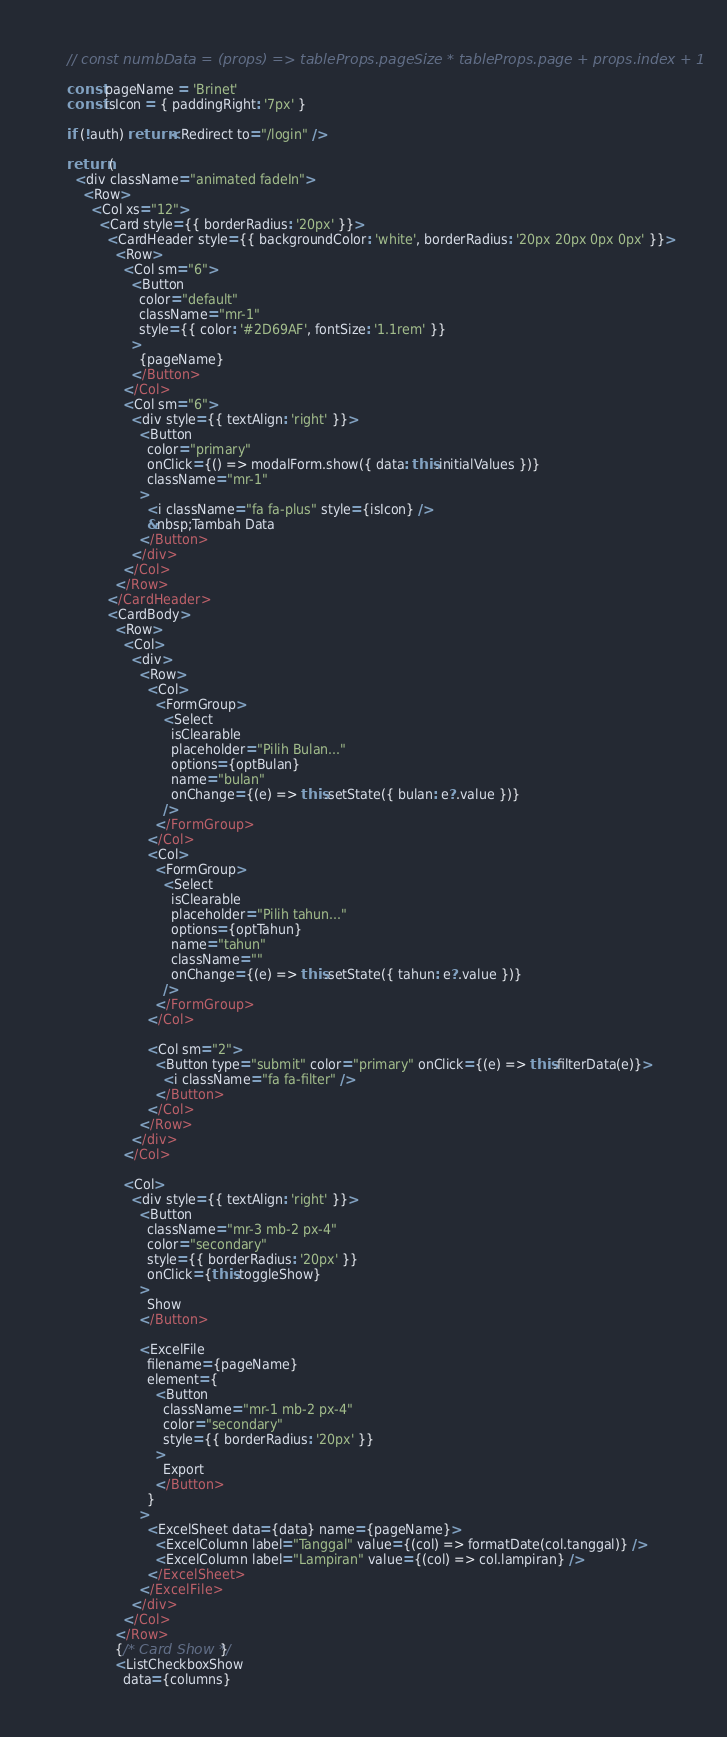<code> <loc_0><loc_0><loc_500><loc_500><_JavaScript_>    // const numbData = (props) => tableProps.pageSize * tableProps.page + props.index + 1

    const pageName = 'Brinet'
    const isIcon = { paddingRight: '7px' }

    if (!auth) return <Redirect to="/login" />

    return (
      <div className="animated fadeIn">
        <Row>
          <Col xs="12">
            <Card style={{ borderRadius: '20px' }}>
              <CardHeader style={{ backgroundColor: 'white', borderRadius: '20px 20px 0px 0px' }}>
                <Row>
                  <Col sm="6">
                    <Button
                      color="default"
                      className="mr-1"
                      style={{ color: '#2D69AF', fontSize: '1.1rem' }}
                    >
                      {pageName}
                    </Button>
                  </Col>
                  <Col sm="6">
                    <div style={{ textAlign: 'right' }}>
                      <Button
                        color="primary"
                        onClick={() => modalForm.show({ data: this.initialValues })}
                        className="mr-1"
                      >
                        <i className="fa fa-plus" style={isIcon} />
                        &nbsp;Tambah Data
                      </Button>
                    </div>
                  </Col>
                </Row>
              </CardHeader>
              <CardBody>
                <Row>
                  <Col>
                    <div>
                      <Row>
                        <Col>
                          <FormGroup>
                            <Select
                              isClearable
                              placeholder="Pilih Bulan..."
                              options={optBulan}
                              name="bulan"
                              onChange={(e) => this.setState({ bulan: e?.value })}
                            />
                          </FormGroup>
                        </Col>
                        <Col>
                          <FormGroup>
                            <Select
                              isClearable
                              placeholder="Pilih tahun..."
                              options={optTahun}
                              name="tahun"
                              className=""
                              onChange={(e) => this.setState({ tahun: e?.value })}
                            />
                          </FormGroup>
                        </Col>

                        <Col sm="2">
                          <Button type="submit" color="primary" onClick={(e) => this.filterData(e)}>
                            <i className="fa fa-filter" />
                          </Button>
                        </Col>
                      </Row>
                    </div>
                  </Col>

                  <Col>
                    <div style={{ textAlign: 'right' }}>
                      <Button
                        className="mr-3 mb-2 px-4"
                        color="secondary"
                        style={{ borderRadius: '20px' }}
                        onClick={this.toggleShow}
                      >
                        Show
                      </Button>

                      <ExcelFile
                        filename={pageName}
                        element={
                          <Button
                            className="mr-1 mb-2 px-4"
                            color="secondary"
                            style={{ borderRadius: '20px' }}
                          >
                            Export
                          </Button>
                        }
                      >
                        <ExcelSheet data={data} name={pageName}>
                          <ExcelColumn label="Tanggal" value={(col) => formatDate(col.tanggal)} />
                          <ExcelColumn label="Lampiran" value={(col) => col.lampiran} />
                        </ExcelSheet>
                      </ExcelFile>
                    </div>
                  </Col>
                </Row>
                {/* Card Show */}
                <ListCheckboxShow
                  data={columns}</code> 